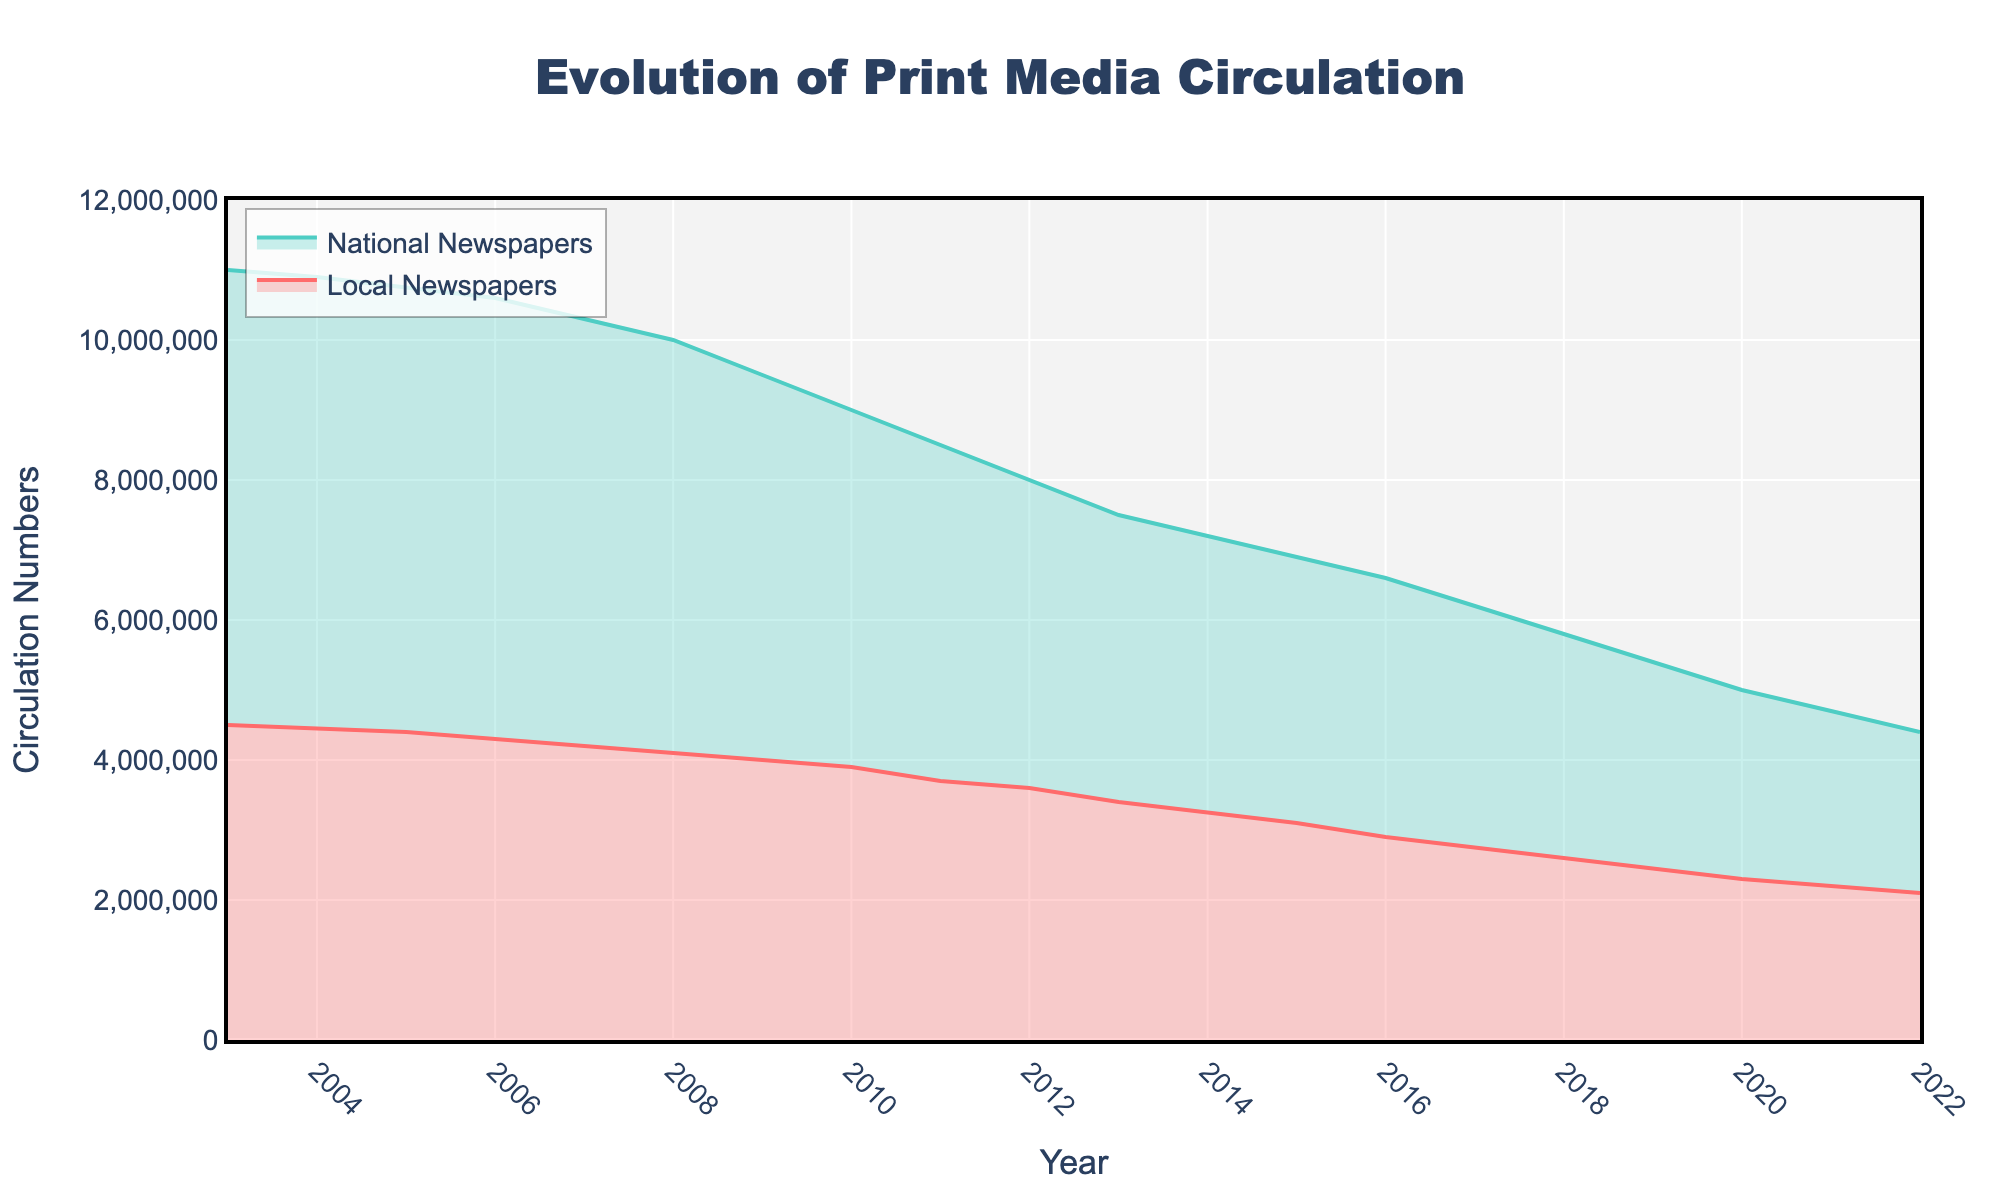What is the title of the figure? The figure's title is prominently displayed at the top.
Answer: Evolution of Print Media Circulation Which type of newspapers had higher circulation numbers in 2005? The Y-axis represents the circulation numbers while the lines differentiate between Local and National Newspapers. The National Newspapers' line is higher in 2005.
Answer: National Newspapers How did the circulation of local newspapers change from 2010 to 2015? The Y-axis shows circulation numbers, and the year's X-axis. Check the values in 2010 and 2015 for Local Newspapers.
Answer: Decreased from 3,900,000 to 3,100,000 In what year did local newspapers' circulation drop below 3 million? Follow the Local Newspapers' line and identify the year where it first goes below 3 million.
Answer: 2016 What's the overall trend observed for National Newspapers' circulation over the 20 years? The continuous step area line for National Newspapers shows a general downward trend from left (earlier years) to right (later years).
Answer: Downward trend By how much did National Newspapers' circulation numbers drop from 2003 to 2022? Subtract the circulation number in 2022 from that in 2003 for National Newspapers (11,000,000 - 4,400,000).
Answer: 6,600,000 Which year did Local Newspapers’ circulation decline rate accelerate, making a noticeable dip? Examine the Local Newspapers' line for a steeper decline over successive years.
Answer: 2009 Do National Newspapers outnumber Local Newspapers at any point in the entire 20 years? By comparing the two lines, it's clear that National Newspapers always have higher circulation numbers than Local Newspapers.
Answer: Yes, throughout the entire period Comparing 2015 to 2019, did the rate of decline in National Newspapers' circulation grow or shrink? Compare the slopes between 2015-2016 and 2019-2020 for National Newspapers. The slope's steepness will indicate the rate of decline.
Answer: Grow 